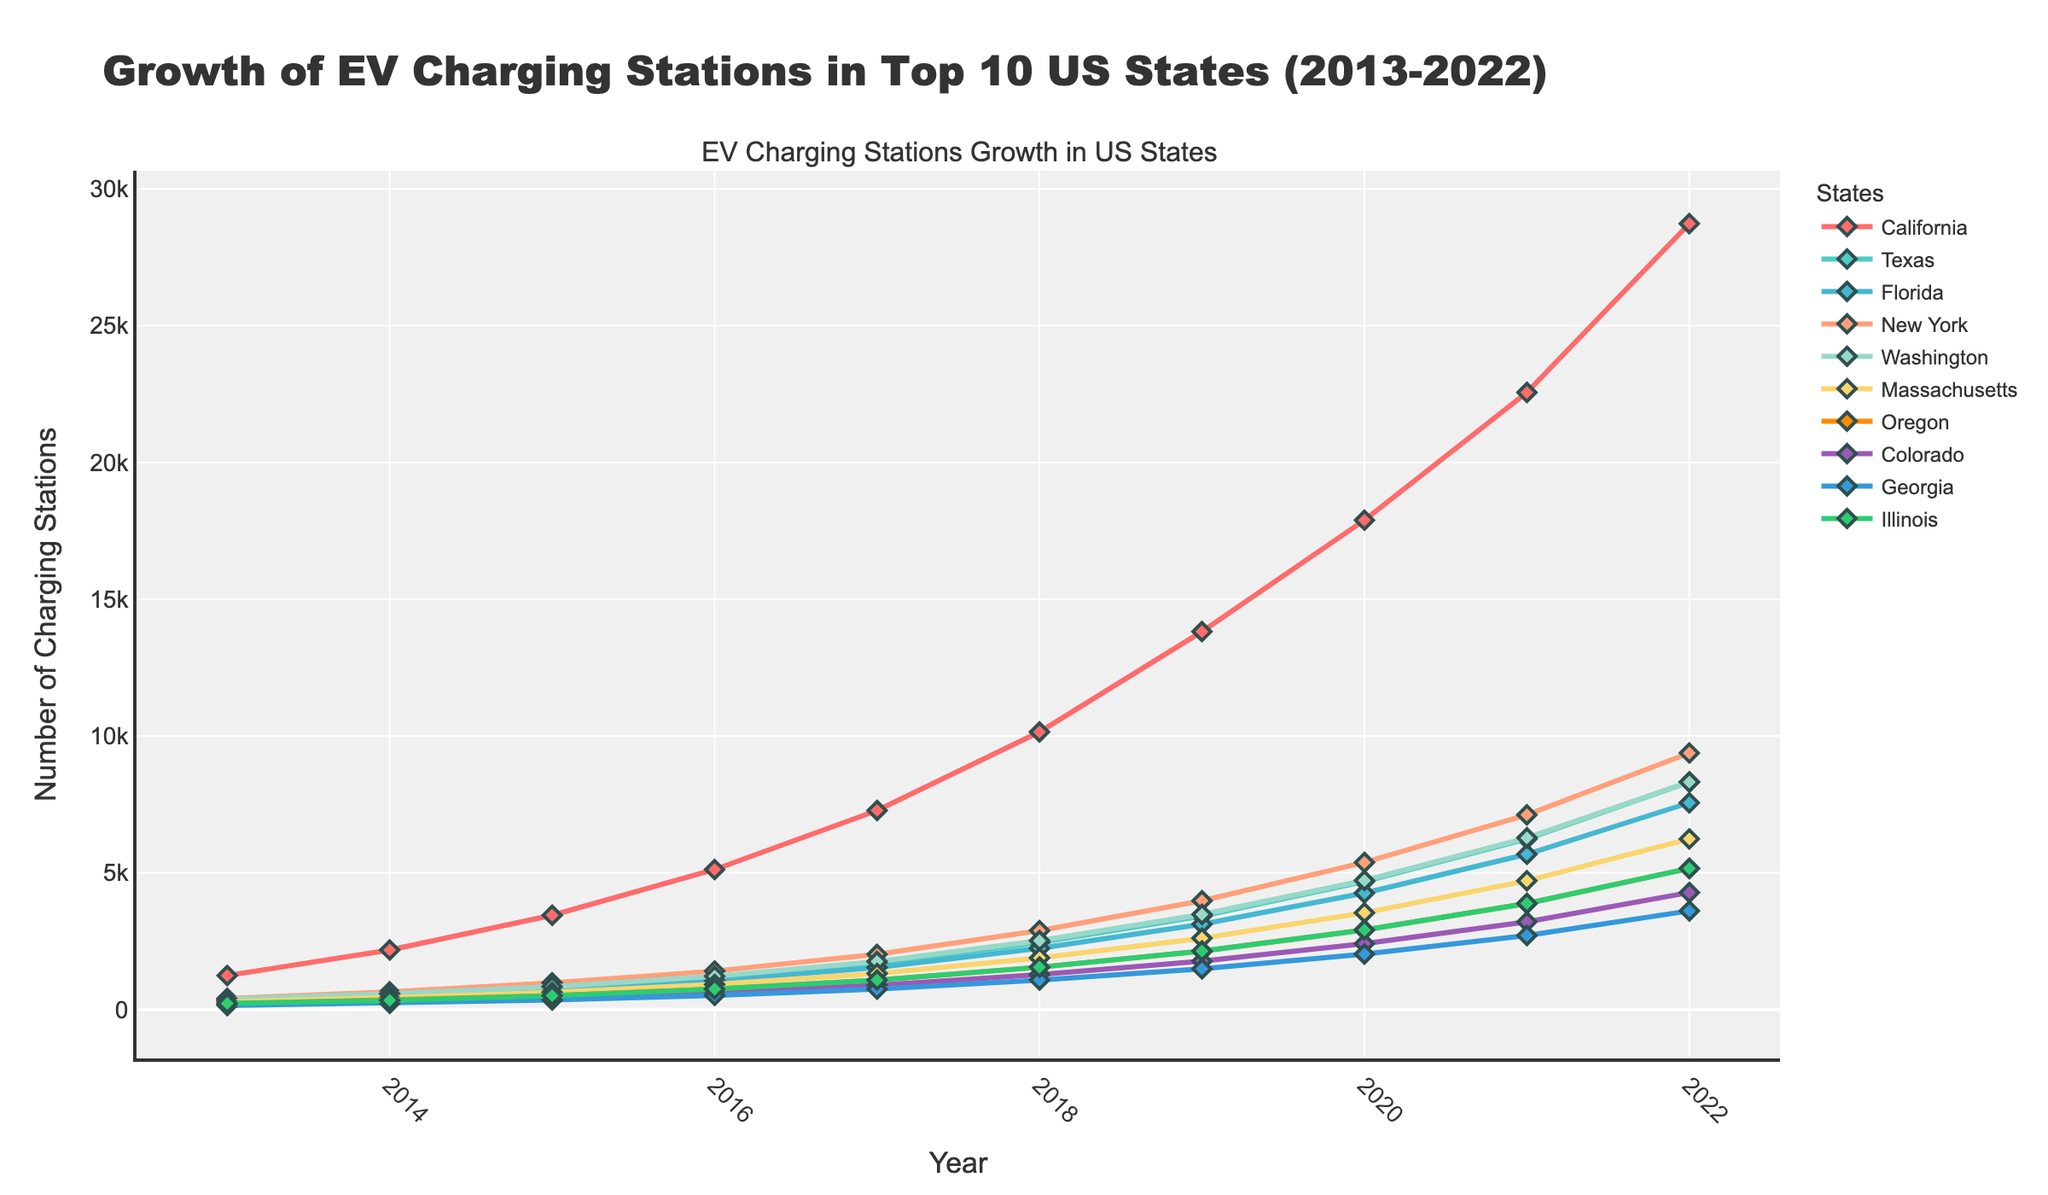Which state had the highest number of charging stations in 2022? Look at the endpoints for each state in the year 2022. California’s line ends at the highest point on the y-axis for that year.
Answer: California Compare the number of charging stations in Texas and Florida in 2019. Which state had more? Check the 2019 data for both states. Texas has 3420, while Florida has 3120. Thus, Texas has more.
Answer: Texas How many charging stations were added in California from 2013 to 2017? Subtract the number for 2013 from the number for 2017 (7280 - 1245).
Answer: 6035 Which state's charging stations grew the fastest from 2020 to 2022? Observe the steepest rising line segment between 2020 and 2022 for each state. California's line appears to rise the fastest.
Answer: California In which year did Colorado see a significant increase in the number of charging stations compared to the previous year? Look for the steepest upward slope in Colorado's line. Between 2020 and 2021, the increase is quite noticeable.
Answer: 2021 What is the average number of charging stations in New York from 2013 to 2022? Sum the values from 2013 to 2022 for New York and divide by the number of years (410 + 650 + 980 + 1410 + 2020 + 2890 + 3980 + 5380 + 7120 + 9380) / 10.
Answer: 3382 Which two states had an equal number of charging stations in 2022? Look at the endpoints for 2022. Compare the final y-axis values. Both Washington and Georgia end at 8320 stations.
Answer: Washington and Georgia Did Massachusetts have more charging stations than Illinois in 2016? Compare the y-values for Massachusetts and Illinois in 2016. Massachusetts has 920 while Illinois has 750. Thus, Massachusetts had more.
Answer: Yes What was the difference in the number of charging stations between Oregon and Illinois in 2022? Subtract Illinois’ final value in 2022 from Oregon’s (5160 - 5160).
Answer: 0 Which state showed a gradual increase in charging stations without any sharp rises or drops from 2013 to 2022? Identify a line that steadily climbs without drastic changes. Oregon’s line shows a smooth and gradual increase.
Answer: Oregon 